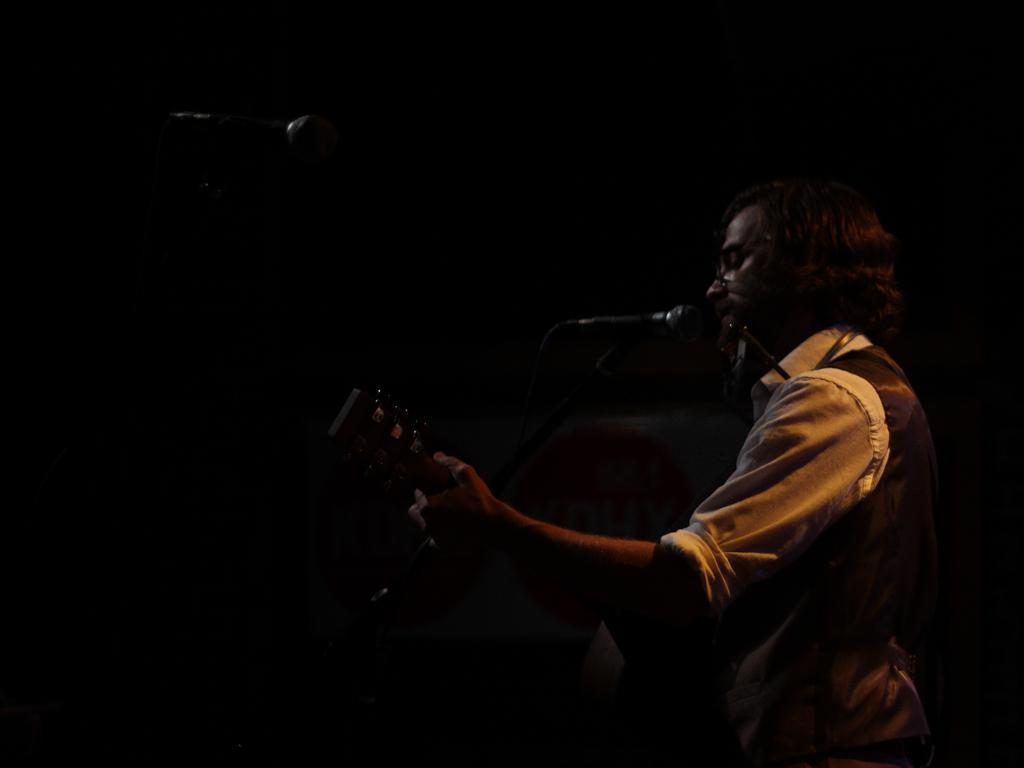What is the person in the image doing? The person in the image is playing a guitar. What objects are present in the image that might be related to the person's activity? There are microphones in the image. Can you see a receipt for the eggs in the image? There is no receipt or eggs present in the image. How many balls are visible in the image? There are no balls visible in the image. 